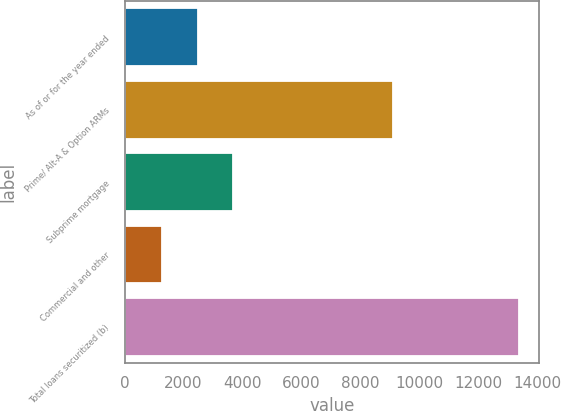Convert chart to OTSL. <chart><loc_0><loc_0><loc_500><loc_500><bar_chart><fcel>As of or for the year ended<fcel>Prime/ Alt-A & Option ARMs<fcel>Subprime mortgage<fcel>Commercial and other<fcel>Total loans securitized (b)<nl><fcel>2478.1<fcel>9118<fcel>3691.2<fcel>1265<fcel>13396<nl></chart> 